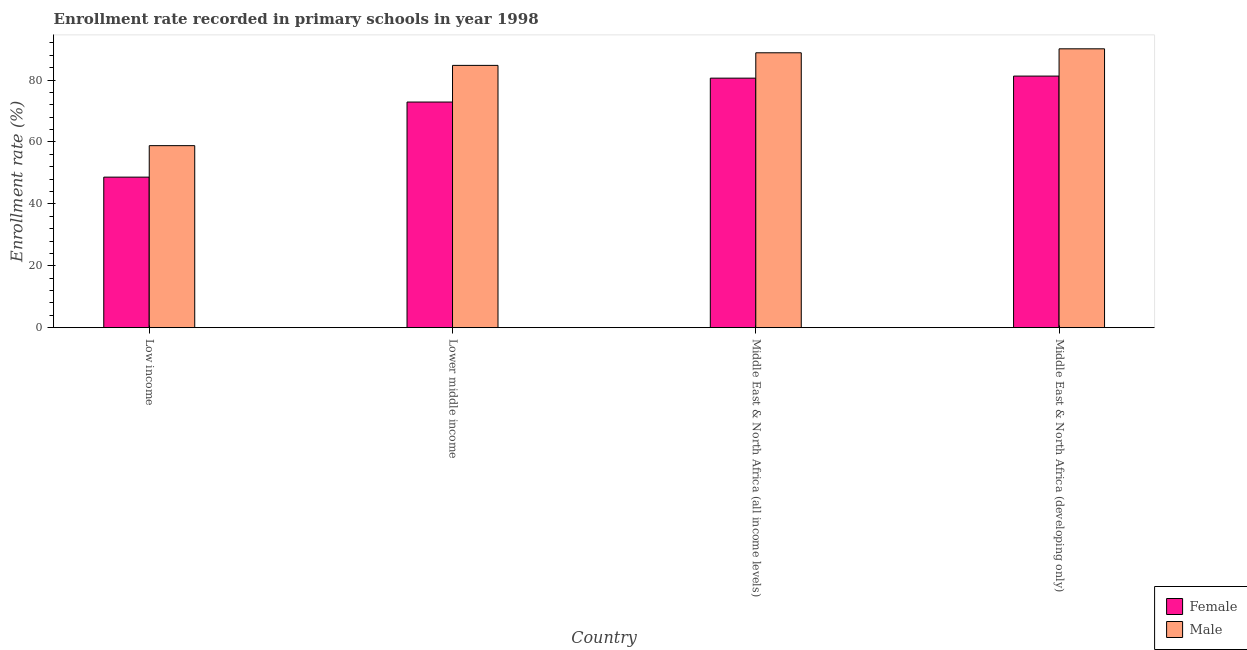How many groups of bars are there?
Ensure brevity in your answer.  4. How many bars are there on the 3rd tick from the right?
Your answer should be very brief. 2. What is the enrollment rate of female students in Lower middle income?
Ensure brevity in your answer.  72.9. Across all countries, what is the maximum enrollment rate of female students?
Provide a short and direct response. 81.29. Across all countries, what is the minimum enrollment rate of female students?
Your answer should be very brief. 48.64. In which country was the enrollment rate of female students maximum?
Offer a very short reply. Middle East & North Africa (developing only). In which country was the enrollment rate of male students minimum?
Ensure brevity in your answer.  Low income. What is the total enrollment rate of male students in the graph?
Your answer should be very brief. 322.46. What is the difference between the enrollment rate of male students in Low income and that in Lower middle income?
Provide a short and direct response. -25.94. What is the difference between the enrollment rate of male students in Low income and the enrollment rate of female students in Middle East & North Africa (all income levels)?
Offer a very short reply. -21.81. What is the average enrollment rate of male students per country?
Offer a terse response. 80.62. What is the difference between the enrollment rate of male students and enrollment rate of female students in Middle East & North Africa (developing only)?
Make the answer very short. 8.81. In how many countries, is the enrollment rate of female students greater than 16 %?
Provide a succinct answer. 4. What is the ratio of the enrollment rate of male students in Low income to that in Lower middle income?
Provide a short and direct response. 0.69. Is the difference between the enrollment rate of male students in Middle East & North Africa (all income levels) and Middle East & North Africa (developing only) greater than the difference between the enrollment rate of female students in Middle East & North Africa (all income levels) and Middle East & North Africa (developing only)?
Your answer should be very brief. No. What is the difference between the highest and the second highest enrollment rate of female students?
Make the answer very short. 0.67. What is the difference between the highest and the lowest enrollment rate of male students?
Ensure brevity in your answer.  31.29. In how many countries, is the enrollment rate of male students greater than the average enrollment rate of male students taken over all countries?
Ensure brevity in your answer.  3. How many bars are there?
Offer a terse response. 8. Are all the bars in the graph horizontal?
Keep it short and to the point. No. What is the difference between two consecutive major ticks on the Y-axis?
Your response must be concise. 20. Does the graph contain any zero values?
Give a very brief answer. No. Does the graph contain grids?
Ensure brevity in your answer.  No. How are the legend labels stacked?
Your answer should be compact. Vertical. What is the title of the graph?
Provide a succinct answer. Enrollment rate recorded in primary schools in year 1998. Does "From human activities" appear as one of the legend labels in the graph?
Your answer should be very brief. No. What is the label or title of the X-axis?
Provide a short and direct response. Country. What is the label or title of the Y-axis?
Offer a terse response. Enrollment rate (%). What is the Enrollment rate (%) of Female in Low income?
Give a very brief answer. 48.64. What is the Enrollment rate (%) of Male in Low income?
Make the answer very short. 58.81. What is the Enrollment rate (%) in Female in Lower middle income?
Keep it short and to the point. 72.9. What is the Enrollment rate (%) in Male in Lower middle income?
Your answer should be compact. 84.75. What is the Enrollment rate (%) in Female in Middle East & North Africa (all income levels)?
Make the answer very short. 80.62. What is the Enrollment rate (%) of Male in Middle East & North Africa (all income levels)?
Give a very brief answer. 88.81. What is the Enrollment rate (%) in Female in Middle East & North Africa (developing only)?
Ensure brevity in your answer.  81.29. What is the Enrollment rate (%) in Male in Middle East & North Africa (developing only)?
Provide a short and direct response. 90.1. Across all countries, what is the maximum Enrollment rate (%) of Female?
Give a very brief answer. 81.29. Across all countries, what is the maximum Enrollment rate (%) of Male?
Your response must be concise. 90.1. Across all countries, what is the minimum Enrollment rate (%) of Female?
Your answer should be compact. 48.64. Across all countries, what is the minimum Enrollment rate (%) of Male?
Keep it short and to the point. 58.81. What is the total Enrollment rate (%) in Female in the graph?
Ensure brevity in your answer.  283.44. What is the total Enrollment rate (%) in Male in the graph?
Offer a very short reply. 322.46. What is the difference between the Enrollment rate (%) of Female in Low income and that in Lower middle income?
Give a very brief answer. -24.26. What is the difference between the Enrollment rate (%) of Male in Low income and that in Lower middle income?
Make the answer very short. -25.94. What is the difference between the Enrollment rate (%) of Female in Low income and that in Middle East & North Africa (all income levels)?
Keep it short and to the point. -31.98. What is the difference between the Enrollment rate (%) of Male in Low income and that in Middle East & North Africa (all income levels)?
Your response must be concise. -30.01. What is the difference between the Enrollment rate (%) in Female in Low income and that in Middle East & North Africa (developing only)?
Your answer should be very brief. -32.65. What is the difference between the Enrollment rate (%) in Male in Low income and that in Middle East & North Africa (developing only)?
Keep it short and to the point. -31.29. What is the difference between the Enrollment rate (%) in Female in Lower middle income and that in Middle East & North Africa (all income levels)?
Offer a very short reply. -7.72. What is the difference between the Enrollment rate (%) in Male in Lower middle income and that in Middle East & North Africa (all income levels)?
Offer a very short reply. -4.07. What is the difference between the Enrollment rate (%) of Female in Lower middle income and that in Middle East & North Africa (developing only)?
Your answer should be very brief. -8.39. What is the difference between the Enrollment rate (%) of Male in Lower middle income and that in Middle East & North Africa (developing only)?
Give a very brief answer. -5.35. What is the difference between the Enrollment rate (%) in Female in Middle East & North Africa (all income levels) and that in Middle East & North Africa (developing only)?
Give a very brief answer. -0.67. What is the difference between the Enrollment rate (%) of Male in Middle East & North Africa (all income levels) and that in Middle East & North Africa (developing only)?
Provide a succinct answer. -1.28. What is the difference between the Enrollment rate (%) of Female in Low income and the Enrollment rate (%) of Male in Lower middle income?
Offer a terse response. -36.11. What is the difference between the Enrollment rate (%) of Female in Low income and the Enrollment rate (%) of Male in Middle East & North Africa (all income levels)?
Your answer should be very brief. -40.18. What is the difference between the Enrollment rate (%) in Female in Low income and the Enrollment rate (%) in Male in Middle East & North Africa (developing only)?
Ensure brevity in your answer.  -41.46. What is the difference between the Enrollment rate (%) of Female in Lower middle income and the Enrollment rate (%) of Male in Middle East & North Africa (all income levels)?
Offer a very short reply. -15.91. What is the difference between the Enrollment rate (%) in Female in Lower middle income and the Enrollment rate (%) in Male in Middle East & North Africa (developing only)?
Ensure brevity in your answer.  -17.2. What is the difference between the Enrollment rate (%) in Female in Middle East & North Africa (all income levels) and the Enrollment rate (%) in Male in Middle East & North Africa (developing only)?
Offer a terse response. -9.48. What is the average Enrollment rate (%) of Female per country?
Your response must be concise. 70.86. What is the average Enrollment rate (%) in Male per country?
Make the answer very short. 80.62. What is the difference between the Enrollment rate (%) of Female and Enrollment rate (%) of Male in Low income?
Your response must be concise. -10.17. What is the difference between the Enrollment rate (%) in Female and Enrollment rate (%) in Male in Lower middle income?
Make the answer very short. -11.85. What is the difference between the Enrollment rate (%) of Female and Enrollment rate (%) of Male in Middle East & North Africa (all income levels)?
Your answer should be very brief. -8.19. What is the difference between the Enrollment rate (%) of Female and Enrollment rate (%) of Male in Middle East & North Africa (developing only)?
Offer a terse response. -8.81. What is the ratio of the Enrollment rate (%) in Female in Low income to that in Lower middle income?
Ensure brevity in your answer.  0.67. What is the ratio of the Enrollment rate (%) in Male in Low income to that in Lower middle income?
Give a very brief answer. 0.69. What is the ratio of the Enrollment rate (%) in Female in Low income to that in Middle East & North Africa (all income levels)?
Make the answer very short. 0.6. What is the ratio of the Enrollment rate (%) of Male in Low income to that in Middle East & North Africa (all income levels)?
Ensure brevity in your answer.  0.66. What is the ratio of the Enrollment rate (%) of Female in Low income to that in Middle East & North Africa (developing only)?
Your answer should be compact. 0.6. What is the ratio of the Enrollment rate (%) in Male in Low income to that in Middle East & North Africa (developing only)?
Offer a terse response. 0.65. What is the ratio of the Enrollment rate (%) in Female in Lower middle income to that in Middle East & North Africa (all income levels)?
Make the answer very short. 0.9. What is the ratio of the Enrollment rate (%) of Male in Lower middle income to that in Middle East & North Africa (all income levels)?
Your answer should be compact. 0.95. What is the ratio of the Enrollment rate (%) in Female in Lower middle income to that in Middle East & North Africa (developing only)?
Give a very brief answer. 0.9. What is the ratio of the Enrollment rate (%) of Male in Lower middle income to that in Middle East & North Africa (developing only)?
Provide a succinct answer. 0.94. What is the ratio of the Enrollment rate (%) in Male in Middle East & North Africa (all income levels) to that in Middle East & North Africa (developing only)?
Make the answer very short. 0.99. What is the difference between the highest and the second highest Enrollment rate (%) in Female?
Provide a short and direct response. 0.67. What is the difference between the highest and the second highest Enrollment rate (%) of Male?
Give a very brief answer. 1.28. What is the difference between the highest and the lowest Enrollment rate (%) in Female?
Provide a succinct answer. 32.65. What is the difference between the highest and the lowest Enrollment rate (%) in Male?
Give a very brief answer. 31.29. 